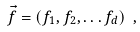<formula> <loc_0><loc_0><loc_500><loc_500>\vec { f } = ( f _ { 1 } , f _ { 2 } , \dots f _ { d } ) \ ,</formula> 